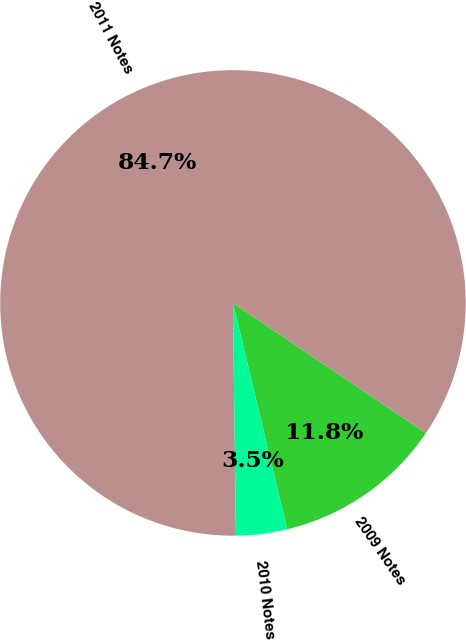Convert chart. <chart><loc_0><loc_0><loc_500><loc_500><pie_chart><fcel>2009 Notes<fcel>2011 Notes<fcel>2010 Notes<nl><fcel>11.81%<fcel>84.65%<fcel>3.54%<nl></chart> 